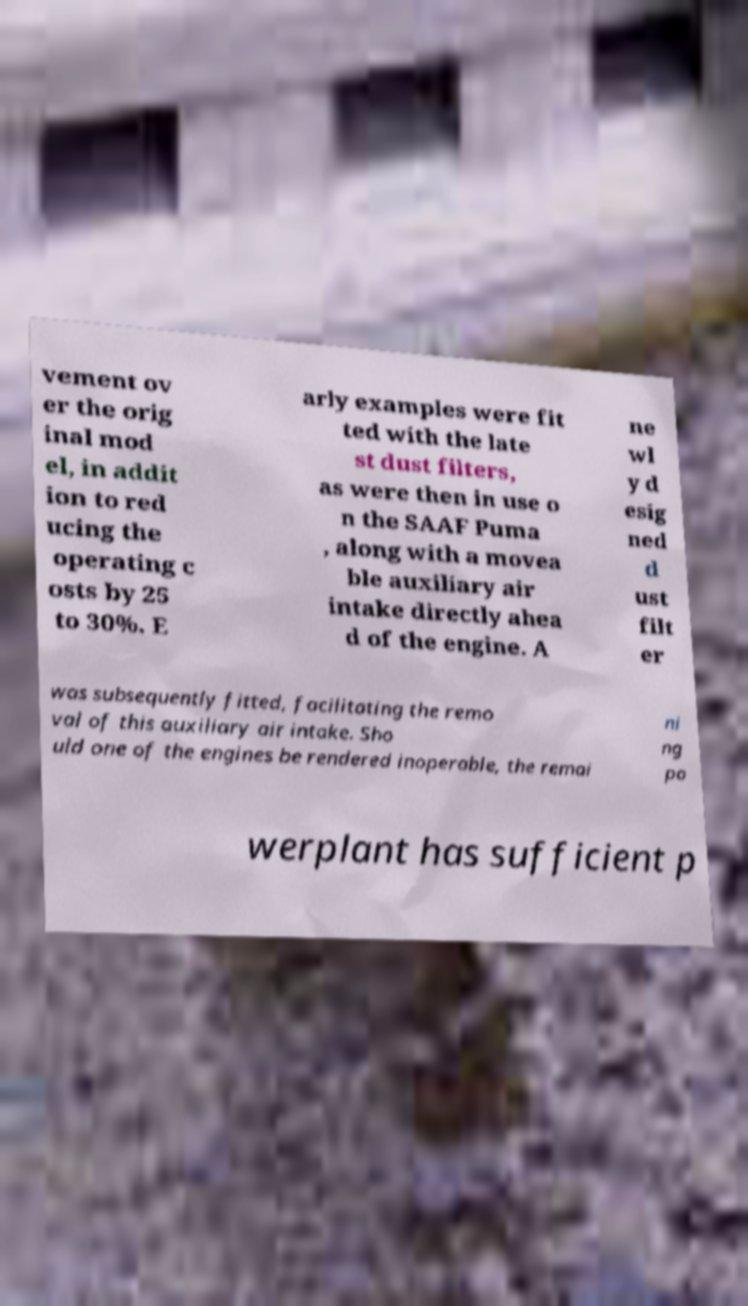Can you read and provide the text displayed in the image?This photo seems to have some interesting text. Can you extract and type it out for me? vement ov er the orig inal mod el, in addit ion to red ucing the operating c osts by 25 to 30%. E arly examples were fit ted with the late st dust filters, as were then in use o n the SAAF Puma , along with a movea ble auxiliary air intake directly ahea d of the engine. A ne wl y d esig ned d ust filt er was subsequently fitted, facilitating the remo val of this auxiliary air intake. Sho uld one of the engines be rendered inoperable, the remai ni ng po werplant has sufficient p 